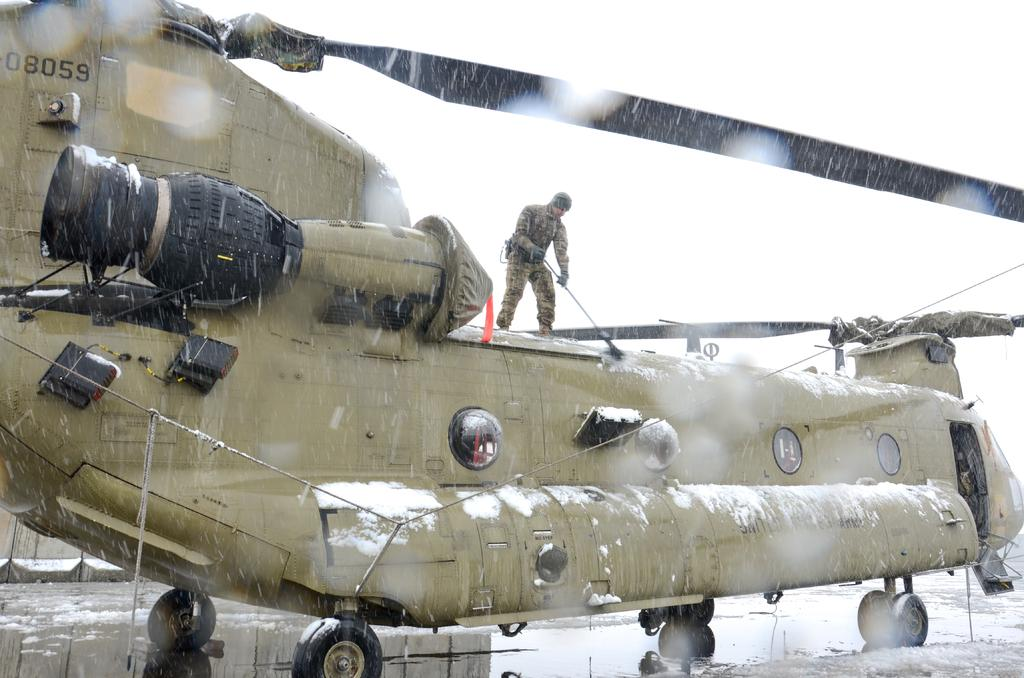<image>
Present a compact description of the photo's key features. The number 08059 is visible on the side of a military helicopter. 